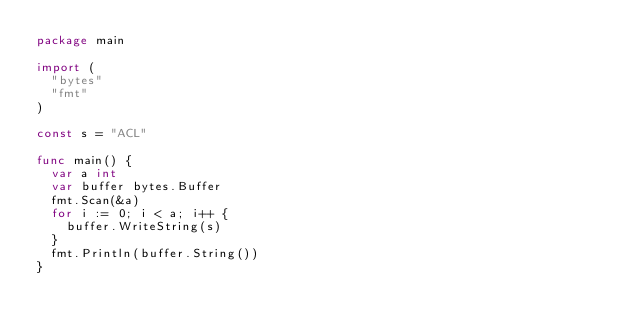Convert code to text. <code><loc_0><loc_0><loc_500><loc_500><_Go_>package main

import (
	"bytes"
	"fmt"
)

const s = "ACL"

func main() {
	var a int
	var buffer bytes.Buffer
	fmt.Scan(&a)
	for i := 0; i < a; i++ {
		buffer.WriteString(s)
	}
	fmt.Println(buffer.String())
}
</code> 